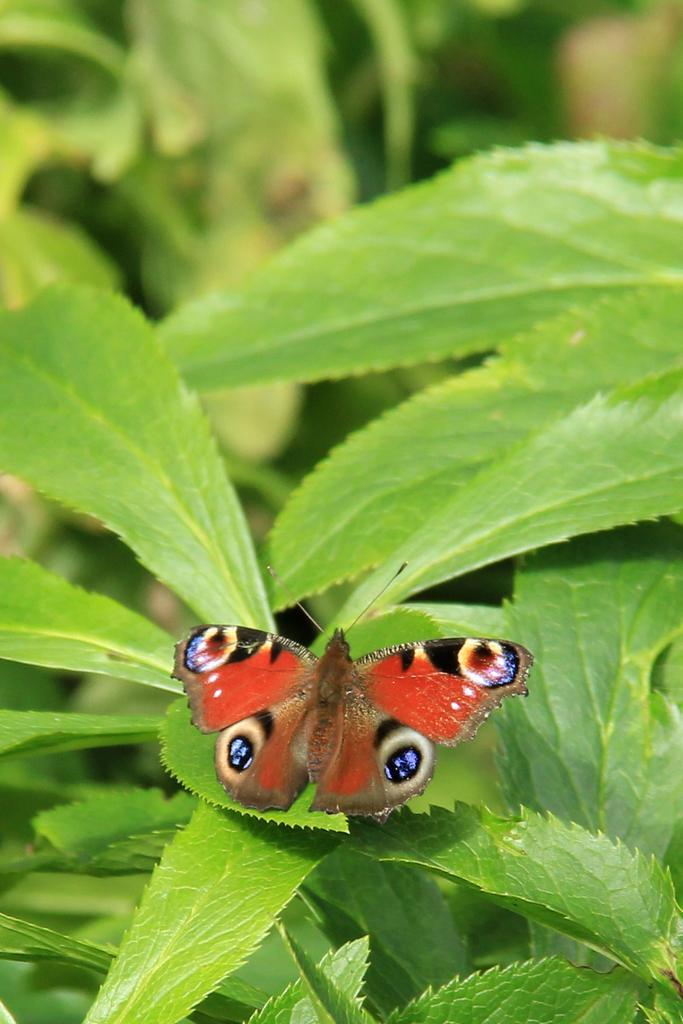Can you describe this image briefly? In this picture, we see butterfly which is red in color is sitting on green color leaf. Beside that, we see plants. 